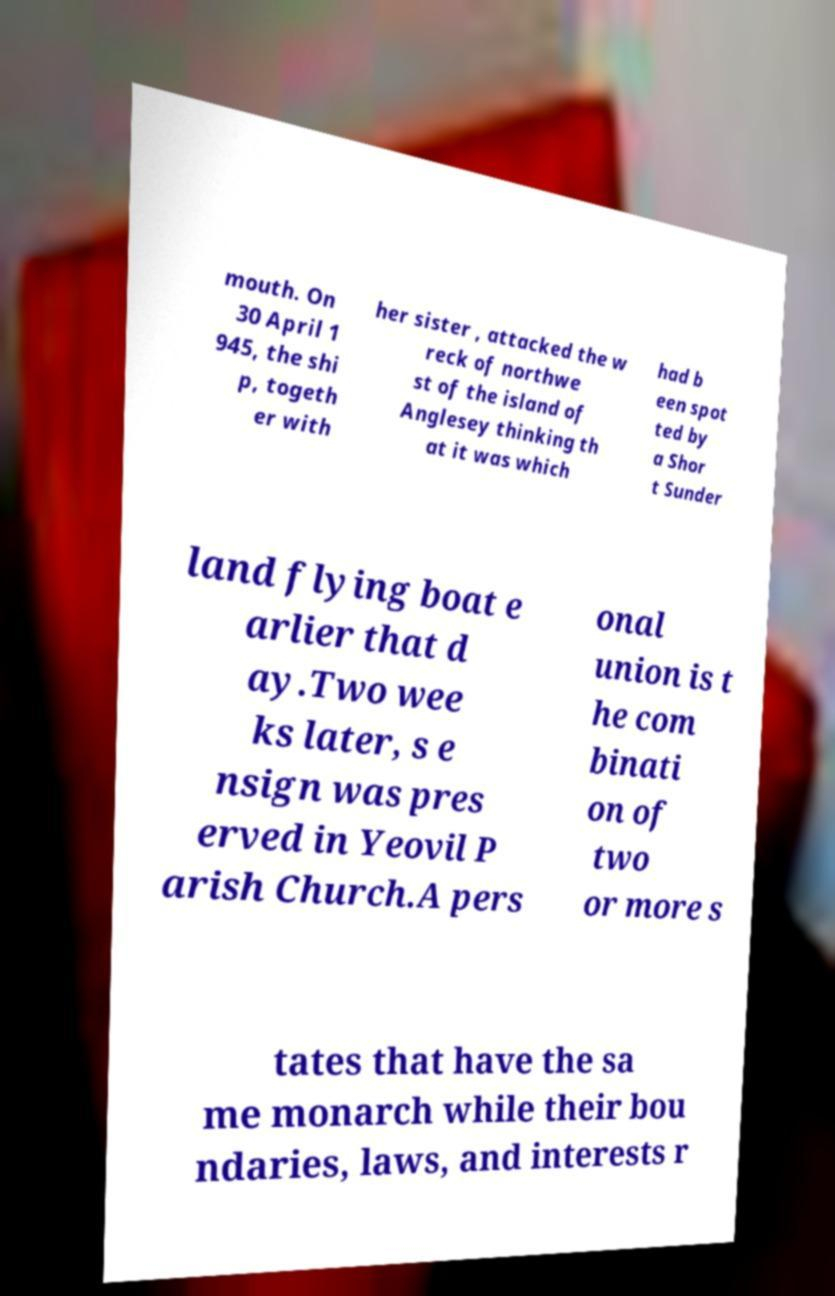Please read and relay the text visible in this image. What does it say? mouth. On 30 April 1 945, the shi p, togeth er with her sister , attacked the w reck of northwe st of the island of Anglesey thinking th at it was which had b een spot ted by a Shor t Sunder land flying boat e arlier that d ay.Two wee ks later, s e nsign was pres erved in Yeovil P arish Church.A pers onal union is t he com binati on of two or more s tates that have the sa me monarch while their bou ndaries, laws, and interests r 